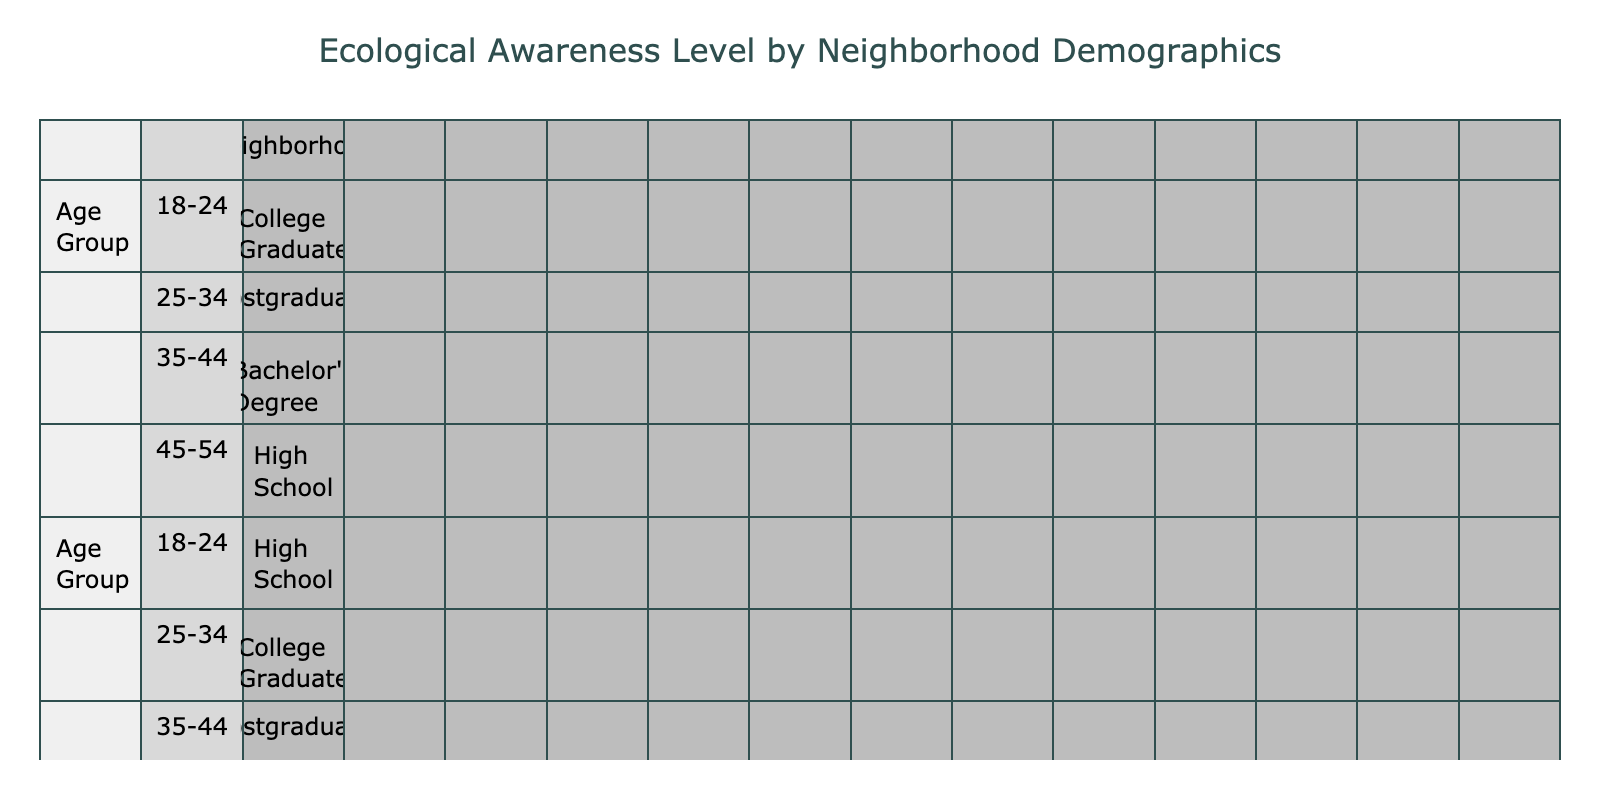What is the Ecological Awareness Level of the 18-24 age group in Greenwood? In the table, I can see that for the neighborhood of Greenwood, the 18-24 age group has an Ecological Awareness Level listed as "High."
Answer: High How many individuals in Maplewood have a Medium Ecological Awareness Level? Looking at the table for the Maplewood neighborhood, I can find one instance of a Medium Ecological Awareness Level under the age group 18-24 and another under the age group 45-54. Therefore, there are a total of 2 individuals with Medium awareness.
Answer: 2 Which Education Level group in Riverbend has the highest Ecological Awareness Level? In Riverbend, the highest Ecological Awareness Level is "Medium," which appears twice among the various Education Levels. There are no instances of High awareness. Therefore, no Education Level group in Riverbend has a higher awareness than Medium.
Answer: Medium Is the average Ecological Awareness Level higher for younger age groups compared to older age groups across all neighborhoods? To answer this, I need to calculate the average awareness level. The younger age groups (18-24, 25-34) have higher instances of High and Medium levels across neighborhoods, while older age groups like 45-54 generally have lower values. Thus, the average for younger groups is indeed higher than for older groups.
Answer: Yes In which neighborhood and age group combination is the Ecological Awareness Level the lowest? Scanning through the table, I can identify that Riverbend in the 18-24 age group has the lowest Ecological Awareness Level, which is classified as "Low."
Answer: Riverbend, 18-24 How does the Ecological Awareness Level for the 35-44 age group compare between Greenwood and Oakridge? In Greenwood, the 35-44 age group has a High awareness level, while in Oakridge, the same age group also has a High level. Therefore, both neighborhoods exhibit the same level of Ecological Awareness for this age group.
Answer: The same (High) 